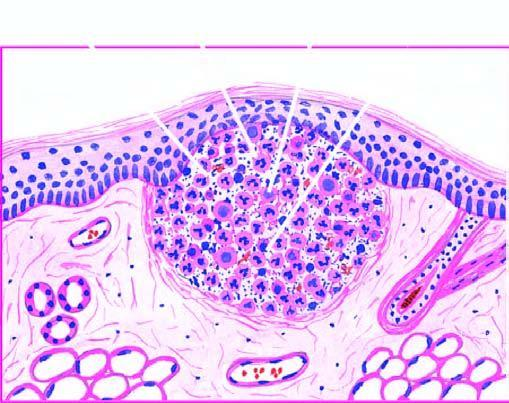what are seen at the periphery?
Answer the question using a single word or phrase. Some macrophages 